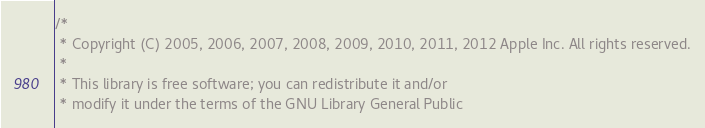<code> <loc_0><loc_0><loc_500><loc_500><_ObjectiveC_>/*
 * Copyright (C) 2005, 2006, 2007, 2008, 2009, 2010, 2011, 2012 Apple Inc. All rights reserved.
 *
 * This library is free software; you can redistribute it and/or
 * modify it under the terms of the GNU Library General Public</code> 